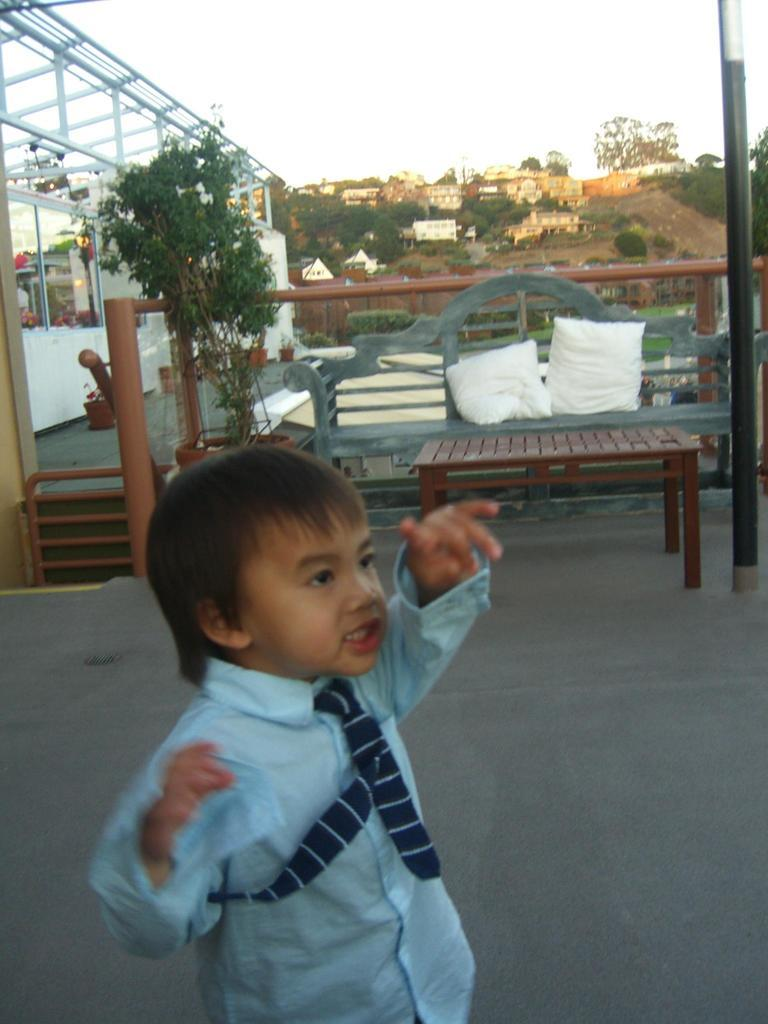What is the main subject of the image? There is a boy standing in the image. What objects or structures can be seen in the image? There is a table, pillows, a wall, a house plant, and a pole visible in the image. What can be seen in the background of the image? Trees, houses, and the sky are visible in the background of the image. How many brothers does the boy have, and what are their names? There is no information about the boy's brothers or their names in the image. What type of trade is being conducted in the image? There is no trade being conducted in the image; it features a boy standing with various objects and structures around him. 